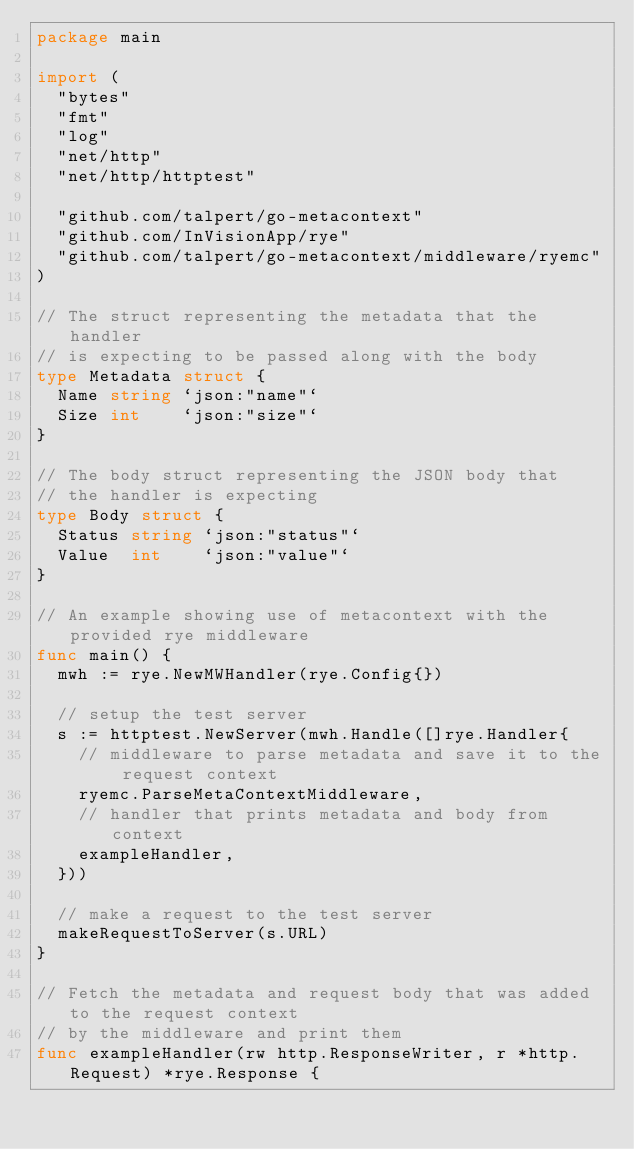Convert code to text. <code><loc_0><loc_0><loc_500><loc_500><_Go_>package main

import (
	"bytes"
	"fmt"
	"log"
	"net/http"
	"net/http/httptest"

	"github.com/talpert/go-metacontext"
	"github.com/InVisionApp/rye"
	"github.com/talpert/go-metacontext/middleware/ryemc"
)

// The struct representing the metadata that the handler
// is expecting to be passed along with the body
type Metadata struct {
	Name string `json:"name"`
	Size int    `json:"size"`
}

// The body struct representing the JSON body that
// the handler is expecting
type Body struct {
	Status string `json:"status"`
	Value  int    `json:"value"`
}

// An example showing use of metacontext with the provided rye middleware
func main() {
	mwh := rye.NewMWHandler(rye.Config{})

	// setup the test server
	s := httptest.NewServer(mwh.Handle([]rye.Handler{
		// middleware to parse metadata and save it to the request context
		ryemc.ParseMetaContextMiddleware,
		// handler that prints metadata and body from context
		exampleHandler,
	}))

	// make a request to the test server
	makeRequestToServer(s.URL)
}

// Fetch the metadata and request body that was added to the request context
// by the middleware and print them
func exampleHandler(rw http.ResponseWriter, r *http.Request) *rye.Response {</code> 